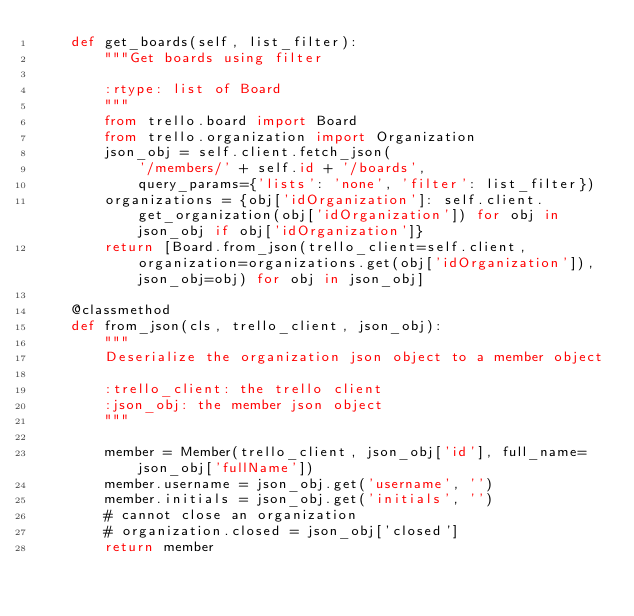<code> <loc_0><loc_0><loc_500><loc_500><_Python_>    def get_boards(self, list_filter):
        """Get boards using filter

        :rtype: list of Board
        """
        from trello.board import Board
        from trello.organization import Organization
        json_obj = self.client.fetch_json(
            '/members/' + self.id + '/boards',
            query_params={'lists': 'none', 'filter': list_filter})
        organizations = {obj['idOrganization']: self.client.get_organization(obj['idOrganization']) for obj in json_obj if obj['idOrganization']}
        return [Board.from_json(trello_client=self.client, organization=organizations.get(obj['idOrganization']), json_obj=obj) for obj in json_obj]

    @classmethod
    def from_json(cls, trello_client, json_obj):
        """
        Deserialize the organization json object to a member object

        :trello_client: the trello client
        :json_obj: the member json object
        """

        member = Member(trello_client, json_obj['id'], full_name=json_obj['fullName'])
        member.username = json_obj.get('username', '')
        member.initials = json_obj.get('initials', '')
        # cannot close an organization
        # organization.closed = json_obj['closed']
        return member
</code> 